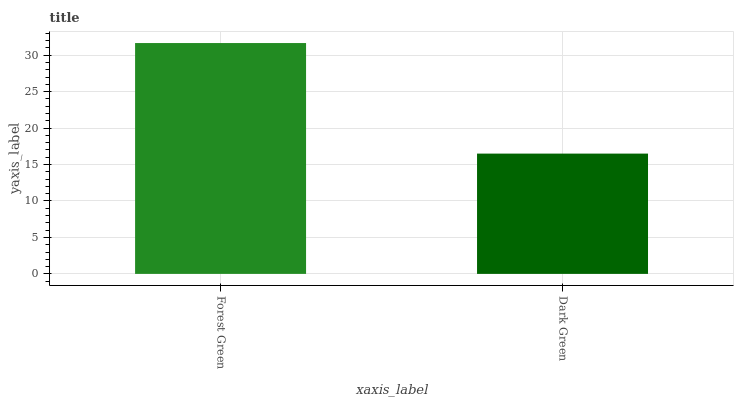Is Dark Green the minimum?
Answer yes or no. Yes. Is Forest Green the maximum?
Answer yes or no. Yes. Is Dark Green the maximum?
Answer yes or no. No. Is Forest Green greater than Dark Green?
Answer yes or no. Yes. Is Dark Green less than Forest Green?
Answer yes or no. Yes. Is Dark Green greater than Forest Green?
Answer yes or no. No. Is Forest Green less than Dark Green?
Answer yes or no. No. Is Forest Green the high median?
Answer yes or no. Yes. Is Dark Green the low median?
Answer yes or no. Yes. Is Dark Green the high median?
Answer yes or no. No. Is Forest Green the low median?
Answer yes or no. No. 